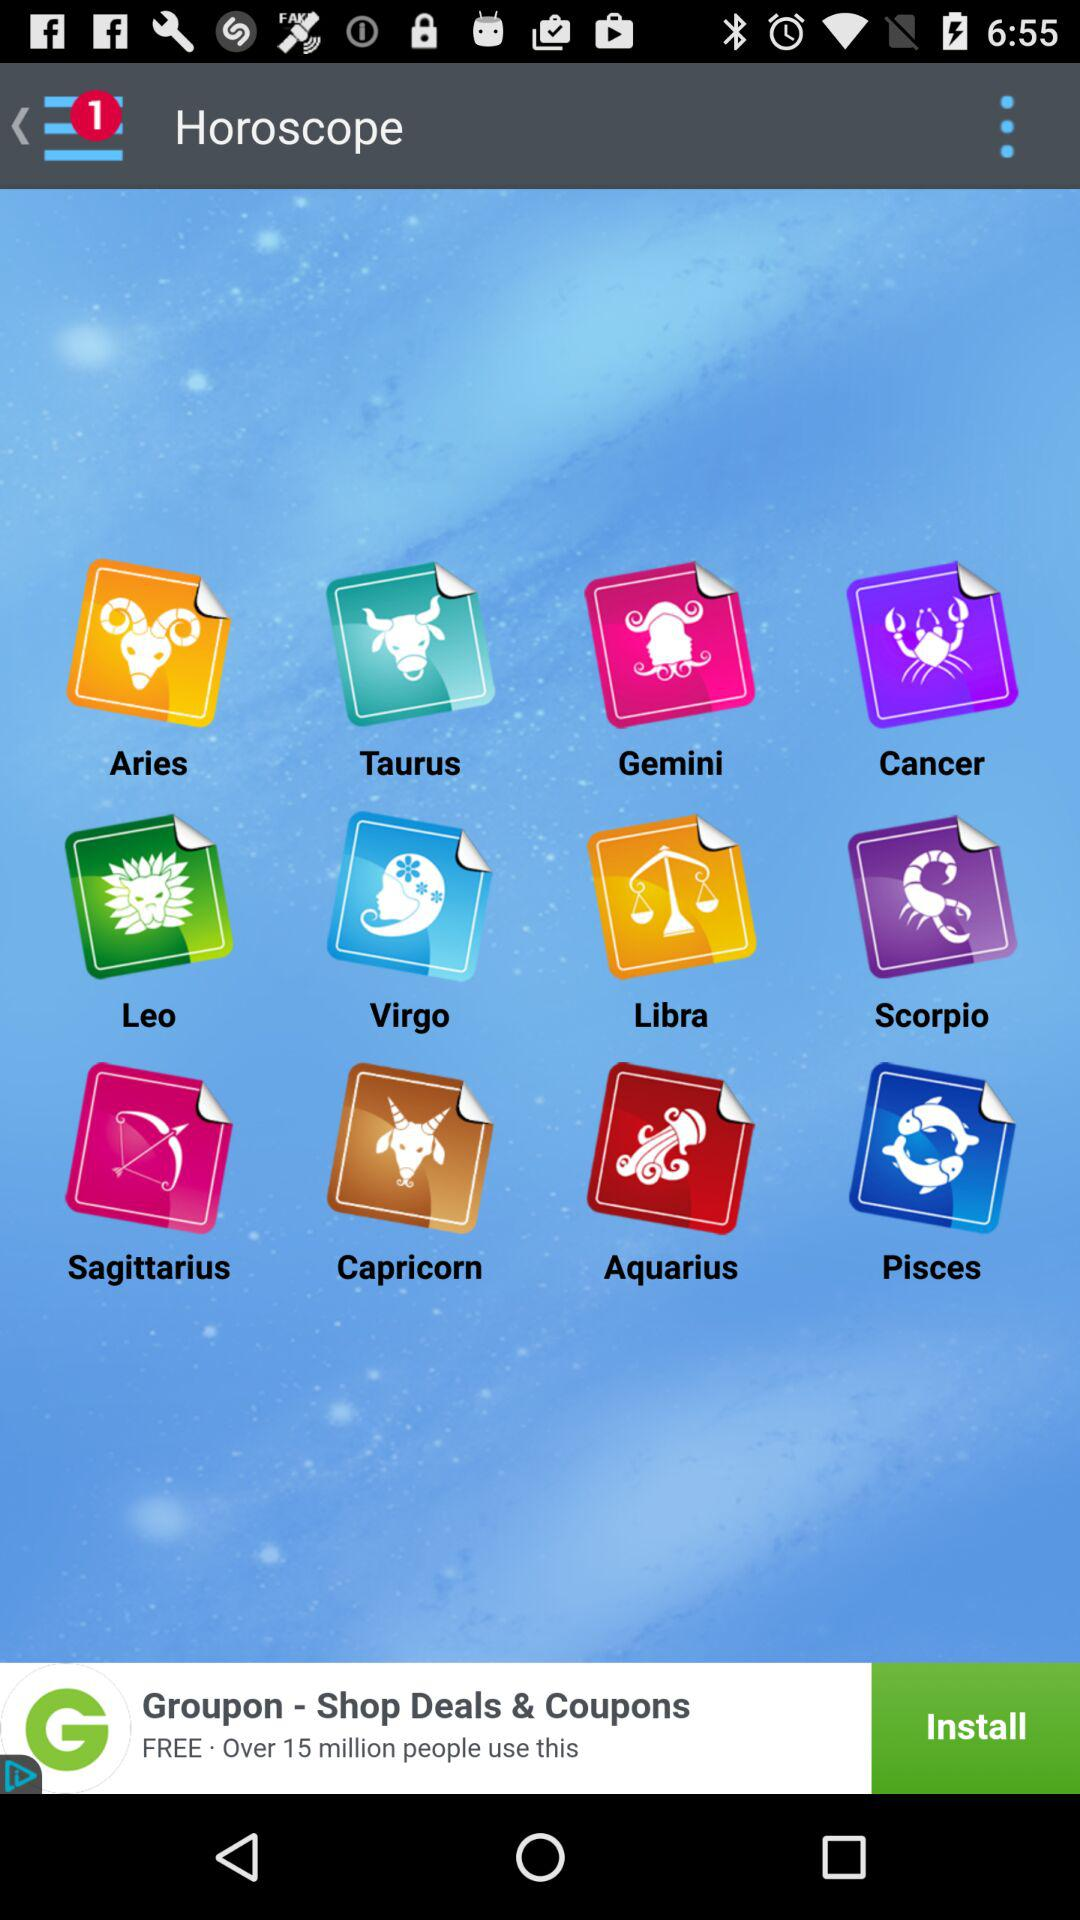What is the name of the application? The name of the application is "Horoscope". 